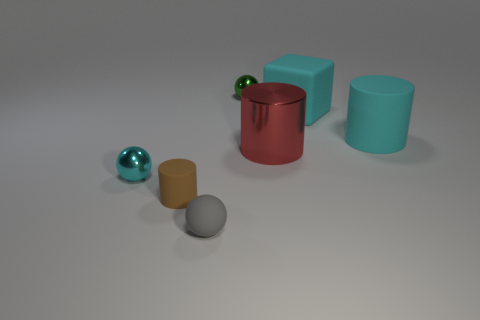Can you tell me the colors of all the objects in the picture? Certainly! In the image, we have a teal rubber cube, a red matte cylinder, a grey matte sphere, a teal shiny sphere, and a tan shiny cylinder. 